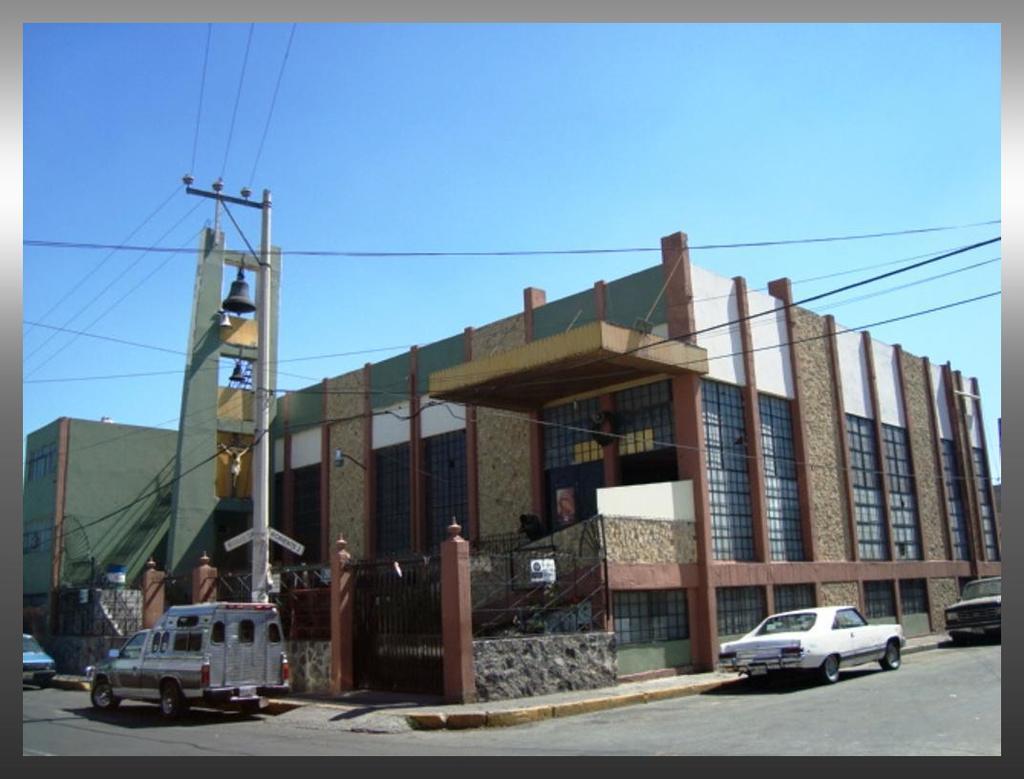In one or two sentences, can you explain what this image depicts? We can see vehicles on the road, current pole, wires, bells, statue on the surface, building, gate, fence and boards. In the background we can see sky. 